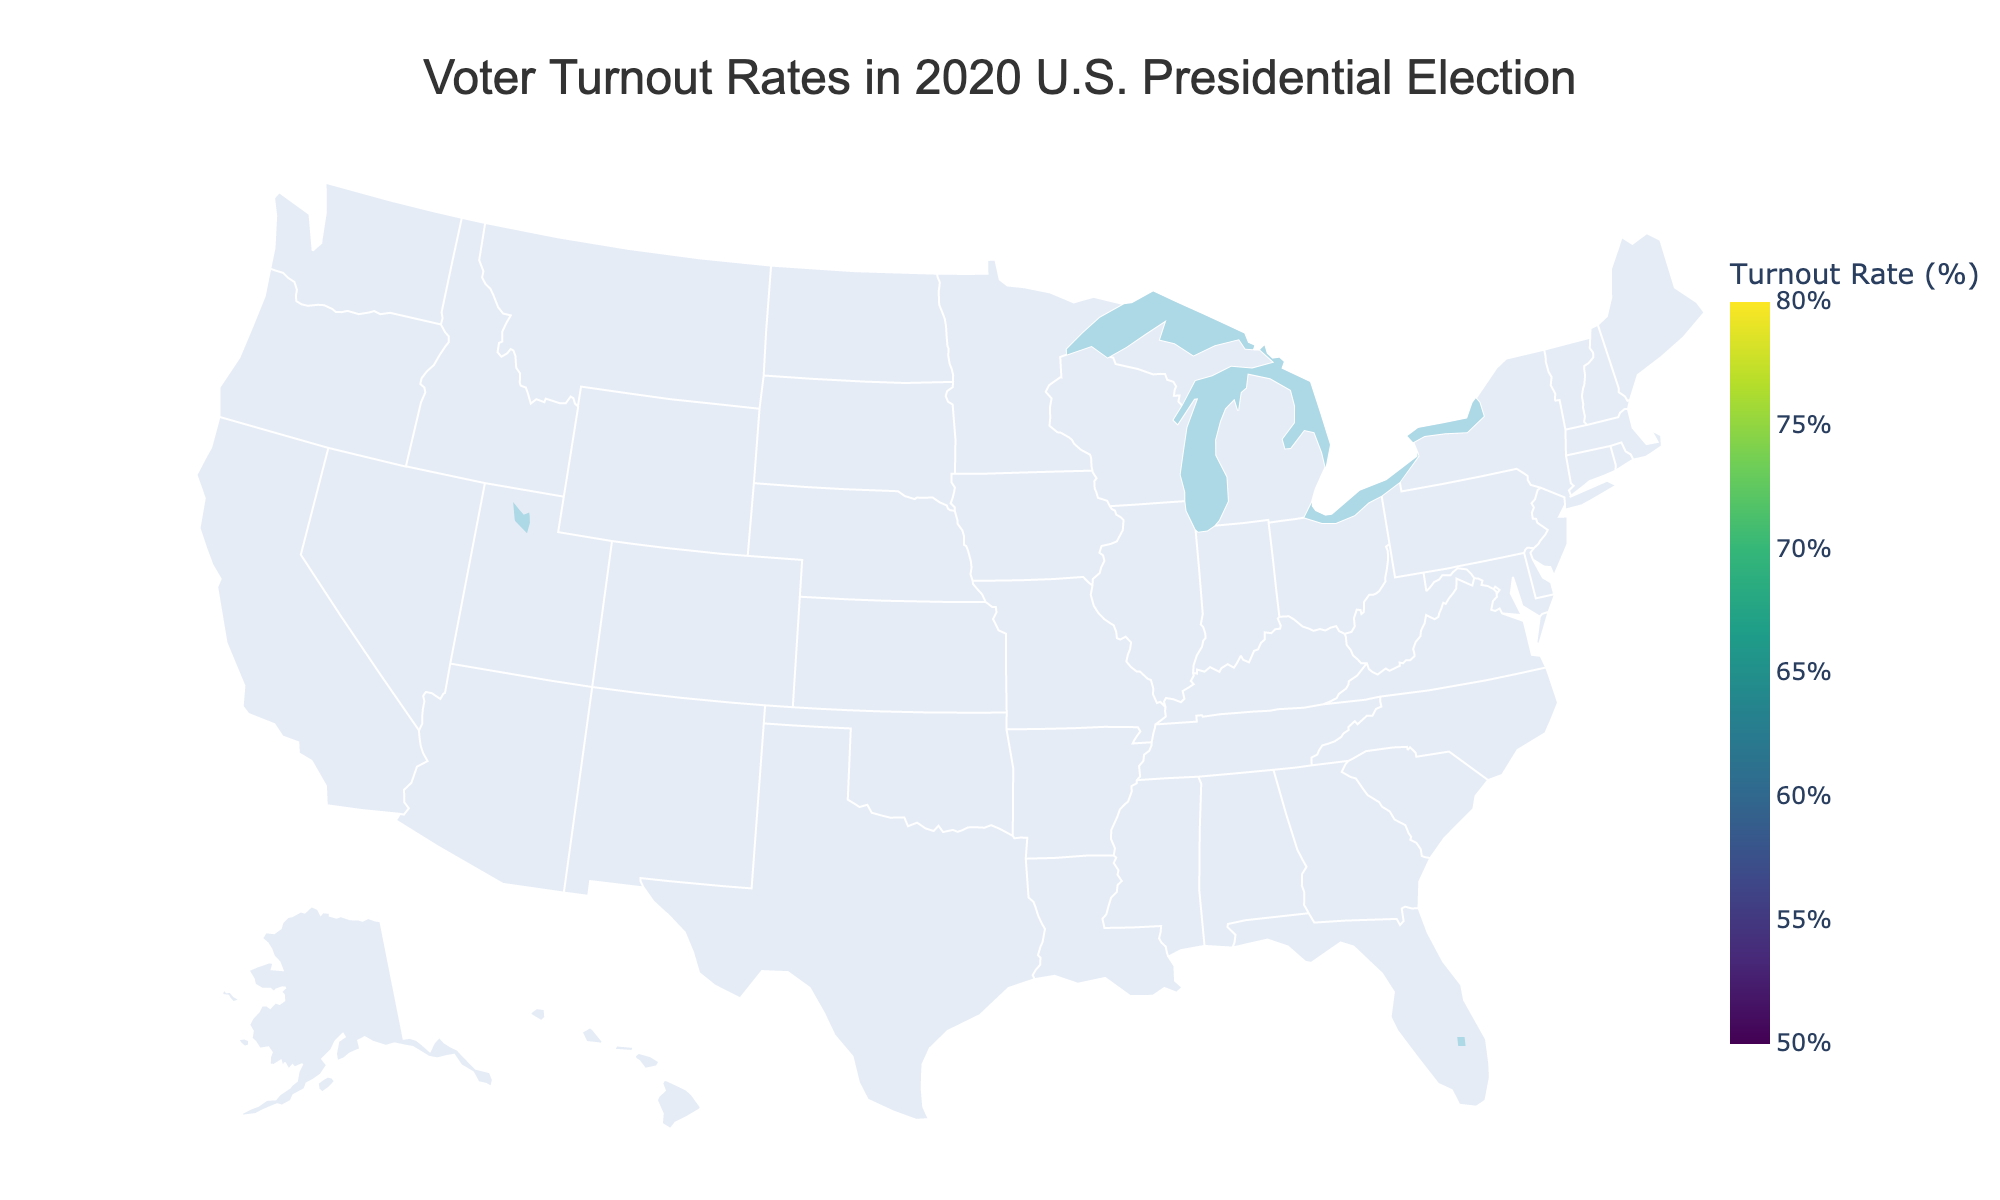What is the title of the figure? The title is usually displayed at the top center of any visual representation. For this figure, it is “Voter Turnout Rates in 2020 U.S. Presidential Election”.
Answer: Voter Turnout Rates in 2020 U.S. Presidential Election Which state has the highest voter turnout rate? To find the state with the highest turnout rate, look for the color indicating the highest value on the color scale or examine the data point with the highest annotated value. Minnesota has the highest voter turnout rate.
Answer: Minnesota What is the turnout rate for Texas? Look for Texas in the figure and note the annotated turnout rate or the corresponding color shade. Texas has a turnout rate of 66.73%.
Answer: 66.73% How many states have a voter turnout rate below 60%? Identify the states with turnout rates under 60% by checking the annotations or colors. The states with rates below 60% are Alabama, Oklahoma, Arkansas, Hawaii, West Virginia, and Tennessee, making a total of 6 states.
Answer: 6 What is the average voter turnout rate of the top 5 states with the highest turnout rates? The top 5 states with the highest turnout rates are Minnesota, Colorado, Maine, Wisconsin, and Oregon. The turnout rates are 79.96%, 76.41%, 75.65%, 75.28%, and 75.22%. The average is calculated as (79.96 + 76.41 + 75.65 + 75.28 + 75.22) / 5 = 76.50%.
Answer: 76.50% Which state has a higher voter turnout rate, New York or California? Compare the turnout rates of New York and California. New York has a turnout rate of 62.40%, while California has a turnout rate of 63.53%. Therefore, California has a higher voter turnout rate than New York.
Answer: California Are there any states with a voter turnout rate between 65% and 70%? Identify the states with turnout rates falling within the specified range by checking the annotations or colors. Georgia, Texas, Arizona, and Nevada have voter turnout rates between 65% and 70%.
Answer: Yes Which region of the USA has the lowest voter turnout rates? To determine which region has the lowest turnout rates, look for the cluster of states with the darkest colors indicating the lowest percentages on the map. The Southern region, including states like Alabama, Mississippi, Arkansas, and Tennessee, shows the lowest voter turnout rates.
Answer: Southern What is the difference in voter turnout rates between Vermont and Florida? Subtract the turnout rate of Florida from that of Vermont. Vermont's turnout rate is 73.88%, and Florida's is 71.69%. The difference is 73.88% - 71.69% = 2.19%.
Answer: 2.19% Which states are the top 3 with the lowest voter turnout rates, and what are their rates? Identify the states with the lowest three voter turnout rates by looking at the colors or annotations. Tennessee (51.92%), West Virginia (52.79%), and Hawaii (53.09%) have the lowest voter turnout rates.
Answer: Tennessee, West Virginia, Hawaii 